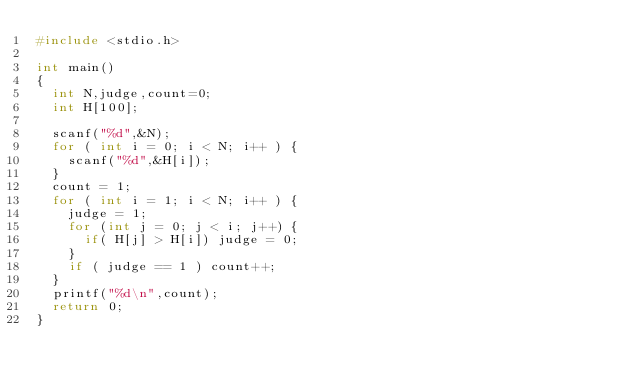<code> <loc_0><loc_0><loc_500><loc_500><_C_>#include <stdio.h>

int main()
{
  int N,judge,count=0;
  int H[100];

  scanf("%d",&N);
  for ( int i = 0; i < N; i++ ) {
    scanf("%d",&H[i]);
  }
  count = 1;
  for ( int i = 1; i < N; i++ ) {
    judge = 1;
    for (int j = 0; j < i; j++) {
      if( H[j] > H[i]) judge = 0;
    }
    if ( judge == 1 ) count++;
  }
  printf("%d\n",count);
  return 0;
}</code> 